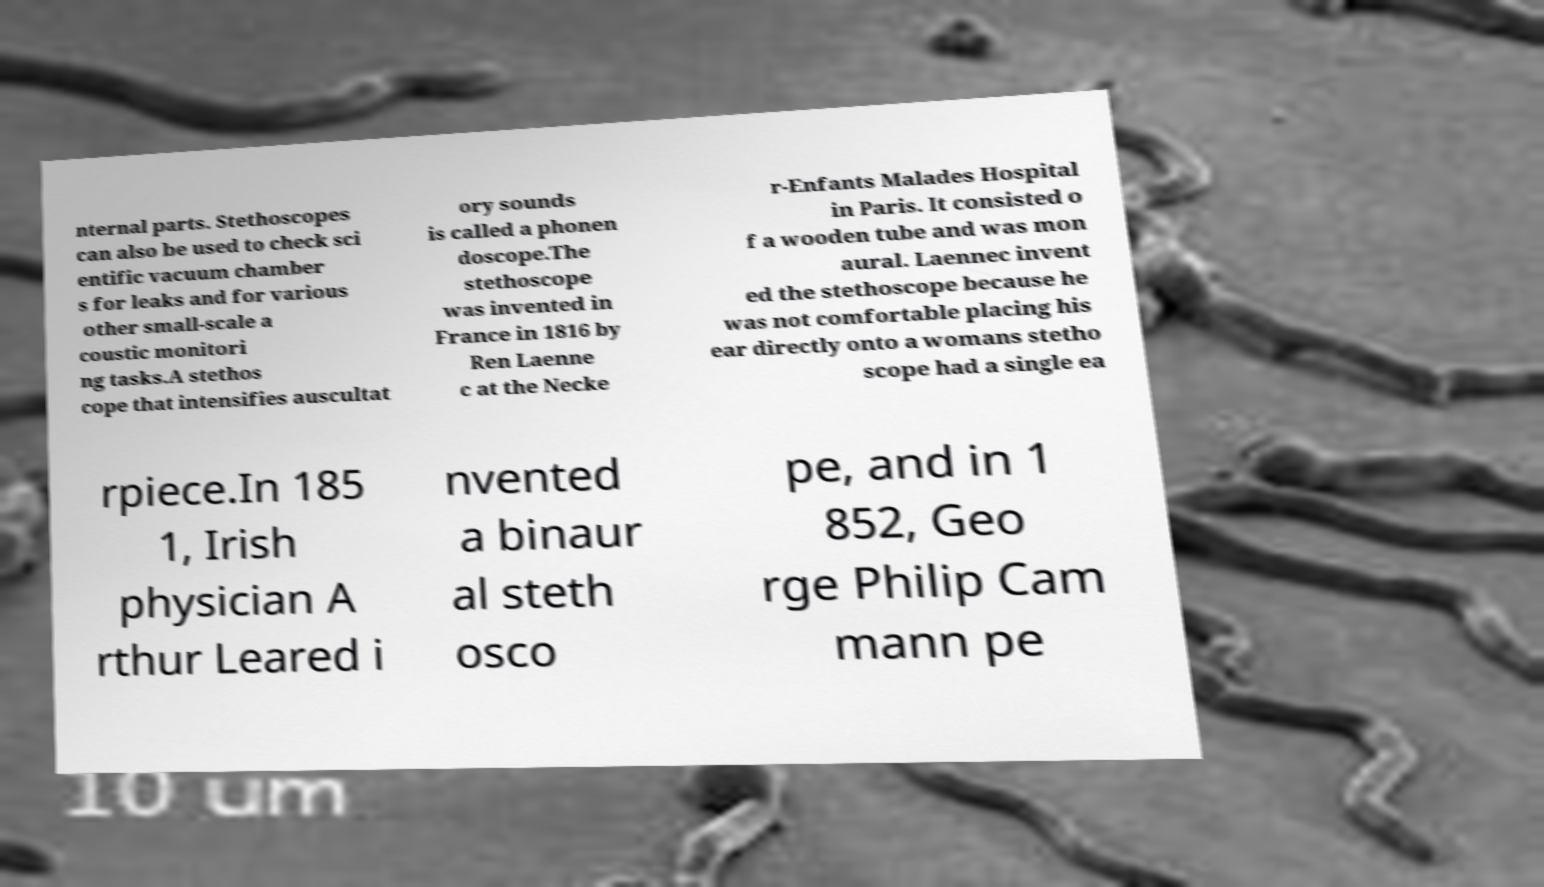Could you extract and type out the text from this image? nternal parts. Stethoscopes can also be used to check sci entific vacuum chamber s for leaks and for various other small-scale a coustic monitori ng tasks.A stethos cope that intensifies auscultat ory sounds is called a phonen doscope.The stethoscope was invented in France in 1816 by Ren Laenne c at the Necke r-Enfants Malades Hospital in Paris. It consisted o f a wooden tube and was mon aural. Laennec invent ed the stethoscope because he was not comfortable placing his ear directly onto a womans stetho scope had a single ea rpiece.In 185 1, Irish physician A rthur Leared i nvented a binaur al steth osco pe, and in 1 852, Geo rge Philip Cam mann pe 